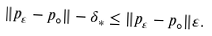<formula> <loc_0><loc_0><loc_500><loc_500>\| p _ { \varepsilon } - p _ { \circ } \| - \delta _ { * } \leq \| p _ { \varepsilon } - p _ { \circ } \| \varepsilon .</formula> 